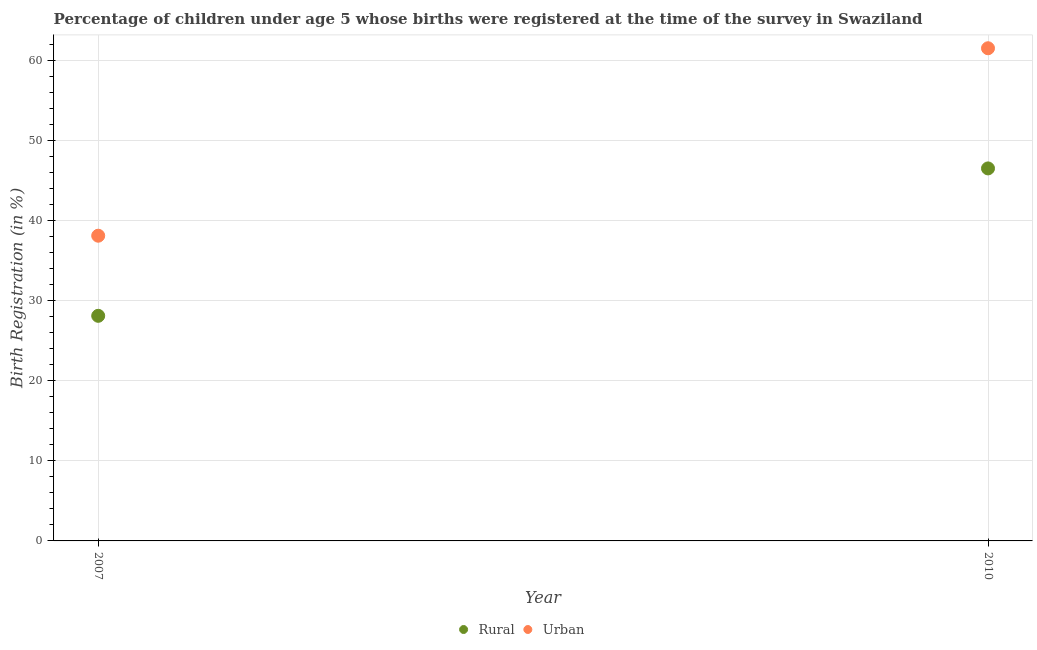Is the number of dotlines equal to the number of legend labels?
Offer a terse response. Yes. What is the urban birth registration in 2010?
Your answer should be very brief. 61.5. Across all years, what is the maximum rural birth registration?
Provide a succinct answer. 46.5. Across all years, what is the minimum rural birth registration?
Give a very brief answer. 28.1. In which year was the urban birth registration maximum?
Your answer should be compact. 2010. In which year was the rural birth registration minimum?
Keep it short and to the point. 2007. What is the total urban birth registration in the graph?
Make the answer very short. 99.6. What is the difference between the urban birth registration in 2007 and that in 2010?
Give a very brief answer. -23.4. What is the difference between the rural birth registration in 2007 and the urban birth registration in 2010?
Offer a very short reply. -33.4. What is the average rural birth registration per year?
Keep it short and to the point. 37.3. In the year 2007, what is the difference between the urban birth registration and rural birth registration?
Keep it short and to the point. 10. In how many years, is the urban birth registration greater than 16 %?
Ensure brevity in your answer.  2. What is the ratio of the urban birth registration in 2007 to that in 2010?
Provide a succinct answer. 0.62. Is the urban birth registration in 2007 less than that in 2010?
Provide a succinct answer. Yes. How many dotlines are there?
Give a very brief answer. 2. How many years are there in the graph?
Keep it short and to the point. 2. What is the difference between two consecutive major ticks on the Y-axis?
Offer a terse response. 10. Are the values on the major ticks of Y-axis written in scientific E-notation?
Your answer should be compact. No. Does the graph contain any zero values?
Your response must be concise. No. Does the graph contain grids?
Offer a terse response. Yes. Where does the legend appear in the graph?
Your answer should be very brief. Bottom center. How many legend labels are there?
Give a very brief answer. 2. What is the title of the graph?
Provide a short and direct response. Percentage of children under age 5 whose births were registered at the time of the survey in Swaziland. Does "Working only" appear as one of the legend labels in the graph?
Offer a very short reply. No. What is the label or title of the X-axis?
Keep it short and to the point. Year. What is the label or title of the Y-axis?
Your answer should be compact. Birth Registration (in %). What is the Birth Registration (in %) in Rural in 2007?
Your response must be concise. 28.1. What is the Birth Registration (in %) in Urban in 2007?
Keep it short and to the point. 38.1. What is the Birth Registration (in %) of Rural in 2010?
Your answer should be very brief. 46.5. What is the Birth Registration (in %) of Urban in 2010?
Provide a succinct answer. 61.5. Across all years, what is the maximum Birth Registration (in %) of Rural?
Keep it short and to the point. 46.5. Across all years, what is the maximum Birth Registration (in %) of Urban?
Keep it short and to the point. 61.5. Across all years, what is the minimum Birth Registration (in %) of Rural?
Make the answer very short. 28.1. Across all years, what is the minimum Birth Registration (in %) in Urban?
Keep it short and to the point. 38.1. What is the total Birth Registration (in %) of Rural in the graph?
Make the answer very short. 74.6. What is the total Birth Registration (in %) in Urban in the graph?
Give a very brief answer. 99.6. What is the difference between the Birth Registration (in %) in Rural in 2007 and that in 2010?
Provide a short and direct response. -18.4. What is the difference between the Birth Registration (in %) of Urban in 2007 and that in 2010?
Provide a short and direct response. -23.4. What is the difference between the Birth Registration (in %) in Rural in 2007 and the Birth Registration (in %) in Urban in 2010?
Your response must be concise. -33.4. What is the average Birth Registration (in %) in Rural per year?
Your answer should be compact. 37.3. What is the average Birth Registration (in %) in Urban per year?
Your answer should be very brief. 49.8. What is the ratio of the Birth Registration (in %) in Rural in 2007 to that in 2010?
Offer a very short reply. 0.6. What is the ratio of the Birth Registration (in %) of Urban in 2007 to that in 2010?
Your answer should be compact. 0.62. What is the difference between the highest and the second highest Birth Registration (in %) of Urban?
Your answer should be very brief. 23.4. What is the difference between the highest and the lowest Birth Registration (in %) of Urban?
Your response must be concise. 23.4. 